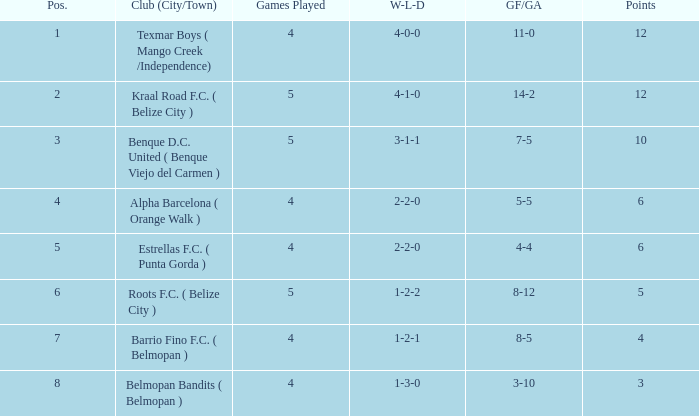What is the minimum games played with goals for/against being 7-5 5.0. 